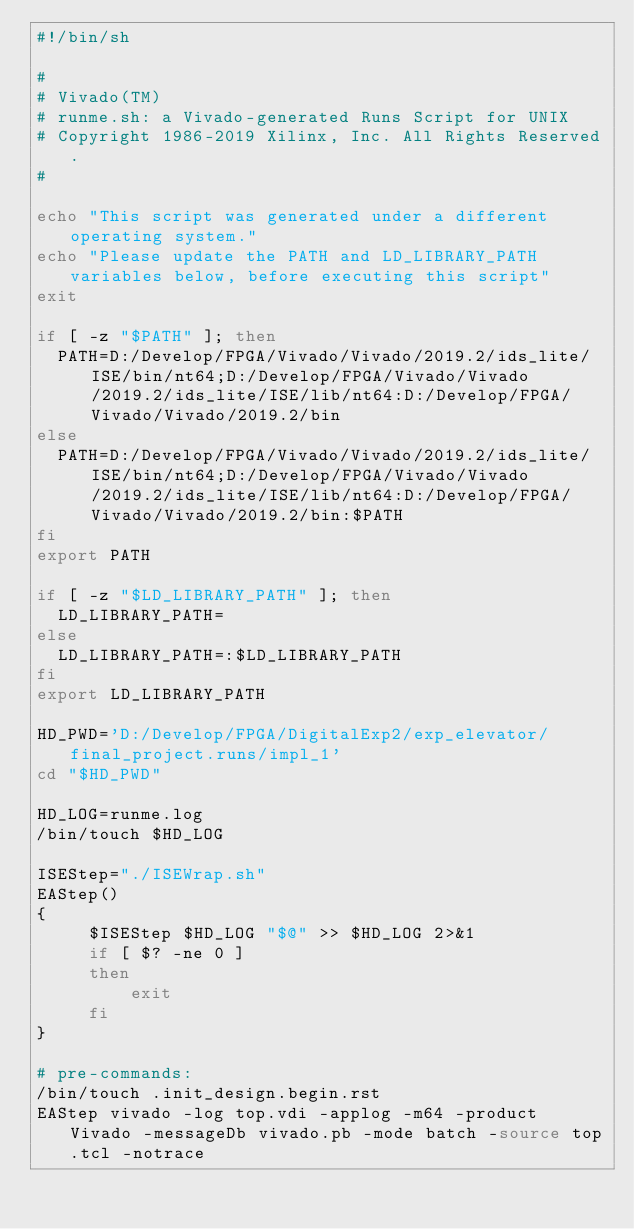<code> <loc_0><loc_0><loc_500><loc_500><_Bash_>#!/bin/sh

# 
# Vivado(TM)
# runme.sh: a Vivado-generated Runs Script for UNIX
# Copyright 1986-2019 Xilinx, Inc. All Rights Reserved.
# 

echo "This script was generated under a different operating system."
echo "Please update the PATH and LD_LIBRARY_PATH variables below, before executing this script"
exit

if [ -z "$PATH" ]; then
  PATH=D:/Develop/FPGA/Vivado/Vivado/2019.2/ids_lite/ISE/bin/nt64;D:/Develop/FPGA/Vivado/Vivado/2019.2/ids_lite/ISE/lib/nt64:D:/Develop/FPGA/Vivado/Vivado/2019.2/bin
else
  PATH=D:/Develop/FPGA/Vivado/Vivado/2019.2/ids_lite/ISE/bin/nt64;D:/Develop/FPGA/Vivado/Vivado/2019.2/ids_lite/ISE/lib/nt64:D:/Develop/FPGA/Vivado/Vivado/2019.2/bin:$PATH
fi
export PATH

if [ -z "$LD_LIBRARY_PATH" ]; then
  LD_LIBRARY_PATH=
else
  LD_LIBRARY_PATH=:$LD_LIBRARY_PATH
fi
export LD_LIBRARY_PATH

HD_PWD='D:/Develop/FPGA/DigitalExp2/exp_elevator/final_project.runs/impl_1'
cd "$HD_PWD"

HD_LOG=runme.log
/bin/touch $HD_LOG

ISEStep="./ISEWrap.sh"
EAStep()
{
     $ISEStep $HD_LOG "$@" >> $HD_LOG 2>&1
     if [ $? -ne 0 ]
     then
         exit
     fi
}

# pre-commands:
/bin/touch .init_design.begin.rst
EAStep vivado -log top.vdi -applog -m64 -product Vivado -messageDb vivado.pb -mode batch -source top.tcl -notrace


</code> 